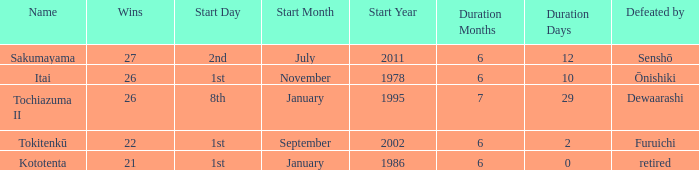How many wins, on average, were defeated by furuichi? 22.0. Help me parse the entirety of this table. {'header': ['Name', 'Wins', 'Start Day', 'Start Month', 'Start Year', 'Duration Months', 'Duration Days', 'Defeated by'], 'rows': [['Sakumayama', '27', '2nd', 'July', '2011', '6', '12', 'Senshō'], ['Itai', '26', '1st', 'November', '1978', '6', '10', 'Ōnishiki'], ['Tochiazuma II', '26', '8th', 'January', '1995', '7', '29', 'Dewaarashi'], ['Tokitenkū', '22', '1st', 'September', '2002', '6', '2', 'Furuichi'], ['Kototenta', '21', '1st', 'January', '1986', '6', '0', 'retired']]} 